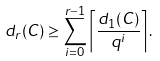Convert formula to latex. <formula><loc_0><loc_0><loc_500><loc_500>d _ { r } ( C ) \geq \sum _ { i = 0 } ^ { r - 1 } \left \lceil \frac { d _ { 1 } ( C ) } { q ^ { i } } \right \rceil .</formula> 